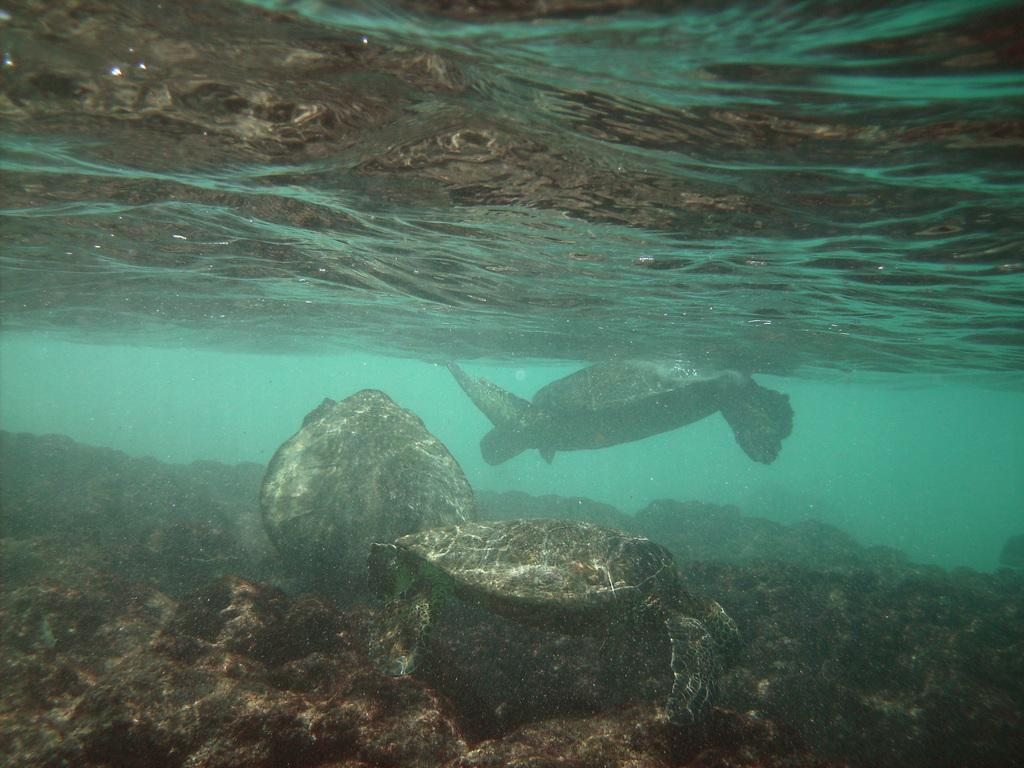What type of animals can be seen in the image? There are turtles in the image. Where are the turtles located? The turtles are under the water. What else can be seen under the water in the image? There are rocks visible under the water in the image. What topic are the turtles discussing in the image? There is no indication in the image that the turtles are having a discussion, as they are underwater and do not have the ability to communicate in a human-like manner. 